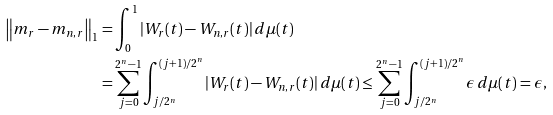<formula> <loc_0><loc_0><loc_500><loc_500>\left \| m _ { r } - m _ { n , r } \right \| _ { 1 } & = \int ^ { 1 } _ { 0 } | W _ { r } ( t ) - W _ { n , r } ( t ) | \, d \mu ( t ) \\ & = \sum ^ { 2 ^ { n } - 1 } _ { j = 0 } \int ^ { ( j + 1 ) / 2 ^ { n } } _ { j / 2 ^ { n } } | W _ { r } ( t ) - W _ { n , r } ( t ) | \, d \mu ( t ) \leq \sum ^ { 2 ^ { n } - 1 } _ { j = 0 } \int ^ { ( j + 1 ) / 2 ^ { n } } _ { j / 2 ^ { n } } \epsilon \, d \mu ( t ) = \epsilon ,</formula> 